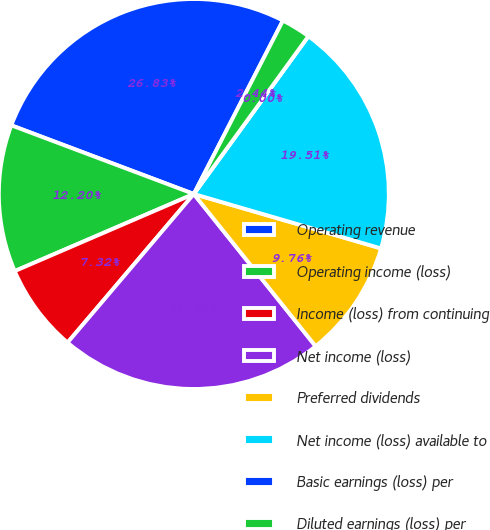Convert chart. <chart><loc_0><loc_0><loc_500><loc_500><pie_chart><fcel>Operating revenue<fcel>Operating income (loss)<fcel>Income (loss) from continuing<fcel>Net income (loss)<fcel>Preferred dividends<fcel>Net income (loss) available to<fcel>Basic earnings (loss) per<fcel>Diluted earnings (loss) per<nl><fcel>26.83%<fcel>12.2%<fcel>7.32%<fcel>21.95%<fcel>9.76%<fcel>19.51%<fcel>0.0%<fcel>2.44%<nl></chart> 